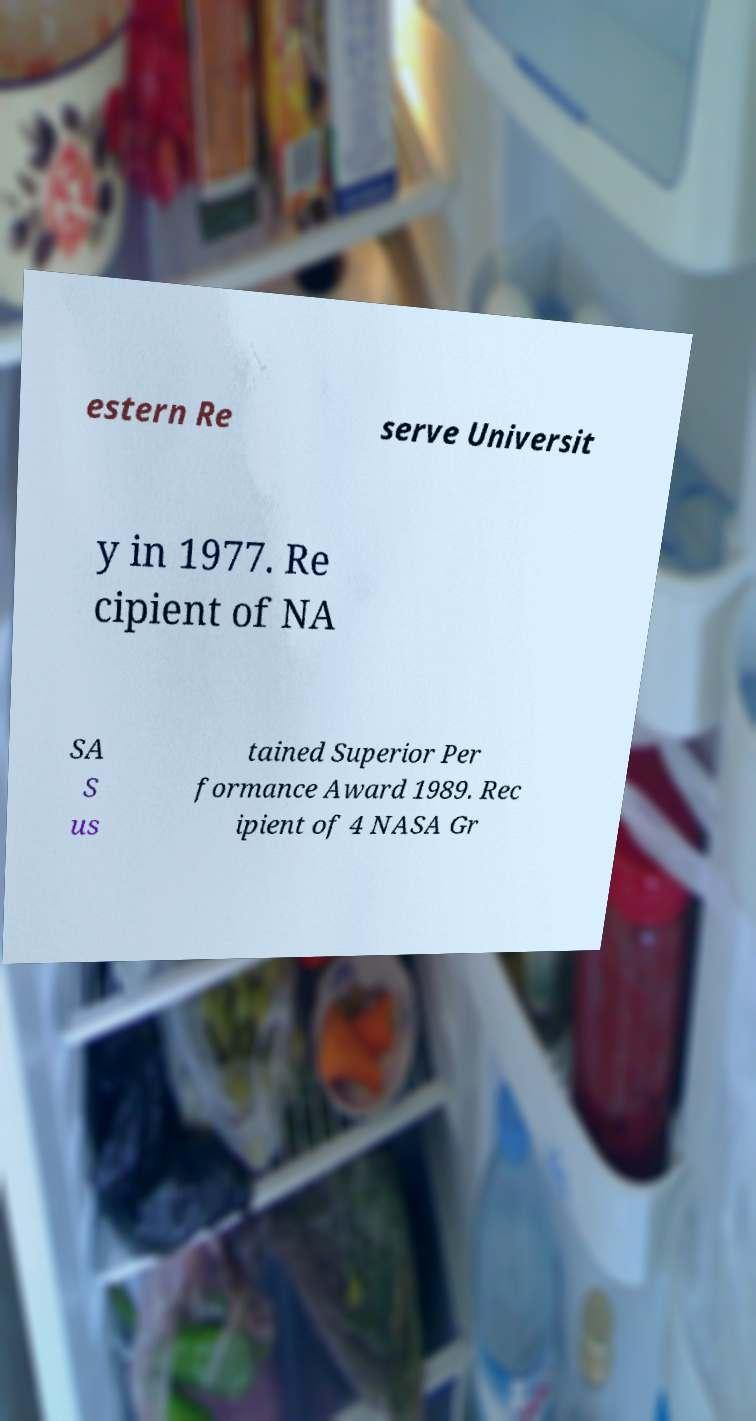There's text embedded in this image that I need extracted. Can you transcribe it verbatim? estern Re serve Universit y in 1977. Re cipient of NA SA S us tained Superior Per formance Award 1989. Rec ipient of 4 NASA Gr 